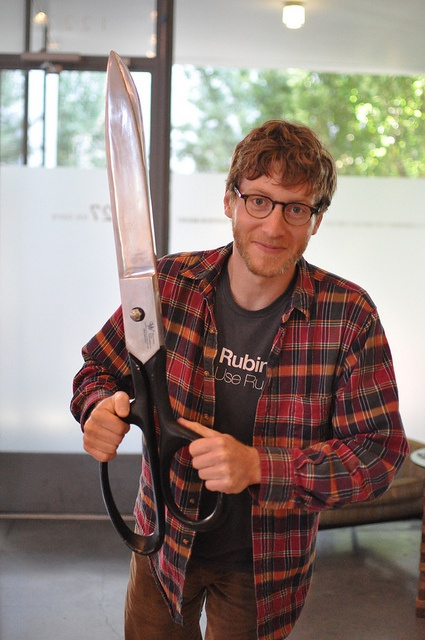Describe the objects in this image and their specific colors. I can see people in darkgray, black, maroon, and brown tones, scissors in darkgray, black, lightgray, and gray tones, and chair in darkgray, black, maroon, and gray tones in this image. 